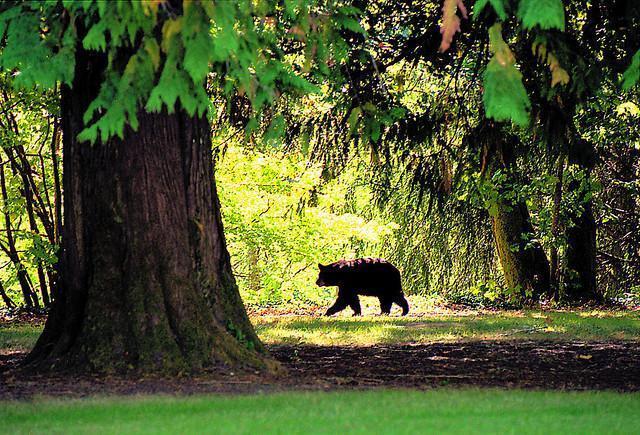How many bears are there?
Give a very brief answer. 1. How many people are riding bikes here?
Give a very brief answer. 0. 